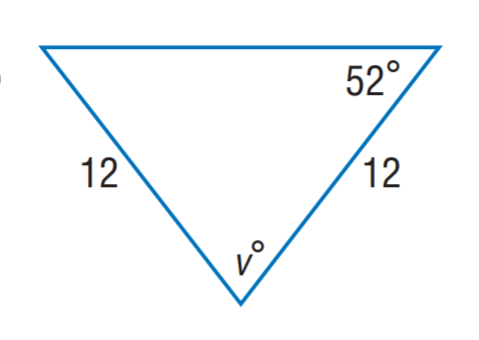Answer the mathemtical geometry problem and directly provide the correct option letter.
Question: Find m \angle v.
Choices: A: 12 B: 52 C: 68 D: 76 D 